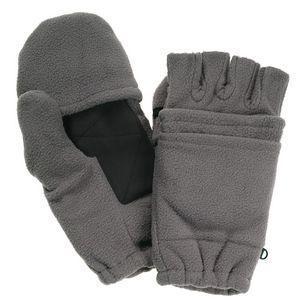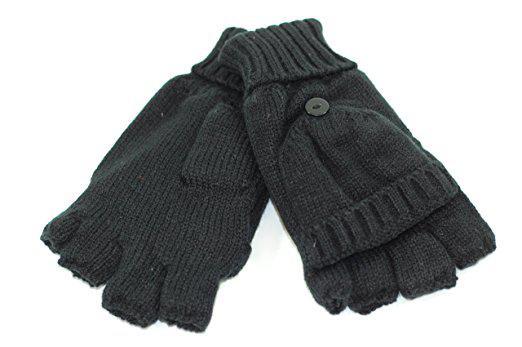The first image is the image on the left, the second image is the image on the right. For the images displayed, is the sentence "The right image shows a pair of gloves modeled on human hands, with one glove displaying fingers while the other glove is covered" factually correct? Answer yes or no. No. The first image is the image on the left, the second image is the image on the right. For the images shown, is this caption "In one of the images, human fingers are visible in only one of the two gloves." true? Answer yes or no. No. 